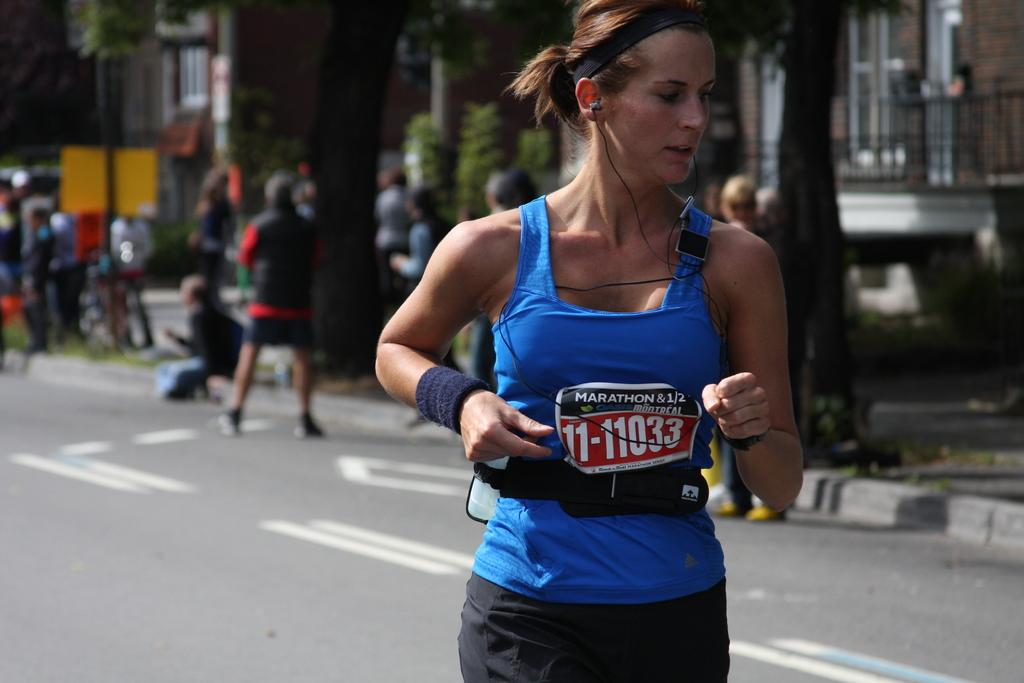Who is the main subject in the image? There is a lady in the image. What is the lady wearing? The lady is wearing a dress. Can you describe the background of the image? There is a blurred image behind the lady. What type of environment is depicted in the image? There is a road, trees, and buildings with walls in the image. Are there any other people in the image besides the lady? Yes, there are people in the image. How much sugar is present in the image? There is no sugar present in the image. Is there any quicksand visible in the image? There is no quicksand visible in the image. 